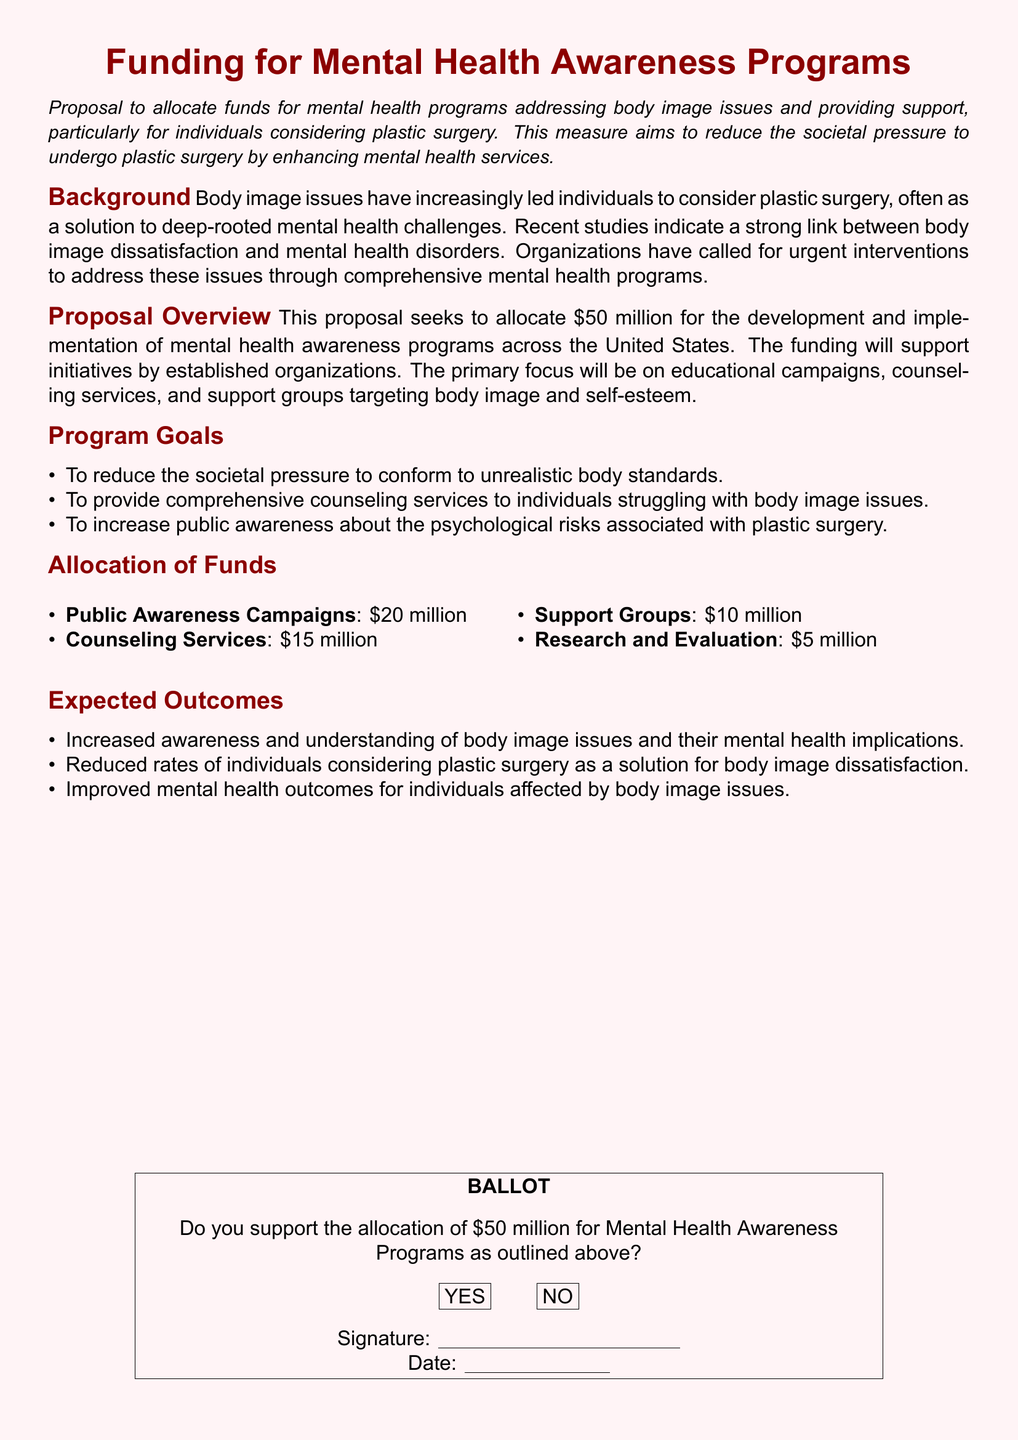What is the proposed funding amount? The proposed funding amount is stated in the document as $50 million for mental health programs.
Answer: $50 million What is the main aim of the proposal? The main aim of the proposal is to reduce societal pressure to undergo plastic surgery by enhancing mental health services.
Answer: Reduce societal pressure What percentage of the funds is allocated to public awareness campaigns? The allocation of funds specifies $20 million for public awareness campaigns out of the total $50 million.
Answer: 40% How much funding is designated for counseling services? The document outlines the funding for counseling services as $15 million.
Answer: $15 million What is one of the expected outcomes of the program? One expected outcome listed in the document is to increase awareness and understanding of body image issues.
Answer: Increased awareness What type of programs does the allocation target? The allocation targets mental health awareness programs specifically addressing body image issues.
Answer: Mental health awareness programs Who is the primary audience for the support initiatives? The primary audience is individuals considering plastic surgery as noted in the proposal.
Answer: Individuals considering plastic surgery Is there a section on program goals? Yes, there is a section outlining specific goals for the proposed programs in the document.
Answer: Yes What is the last item listed in the allocation of funds? The last item listed in the allocation of funds is research and evaluation, which receives $5 million.
Answer: Research and evaluation 